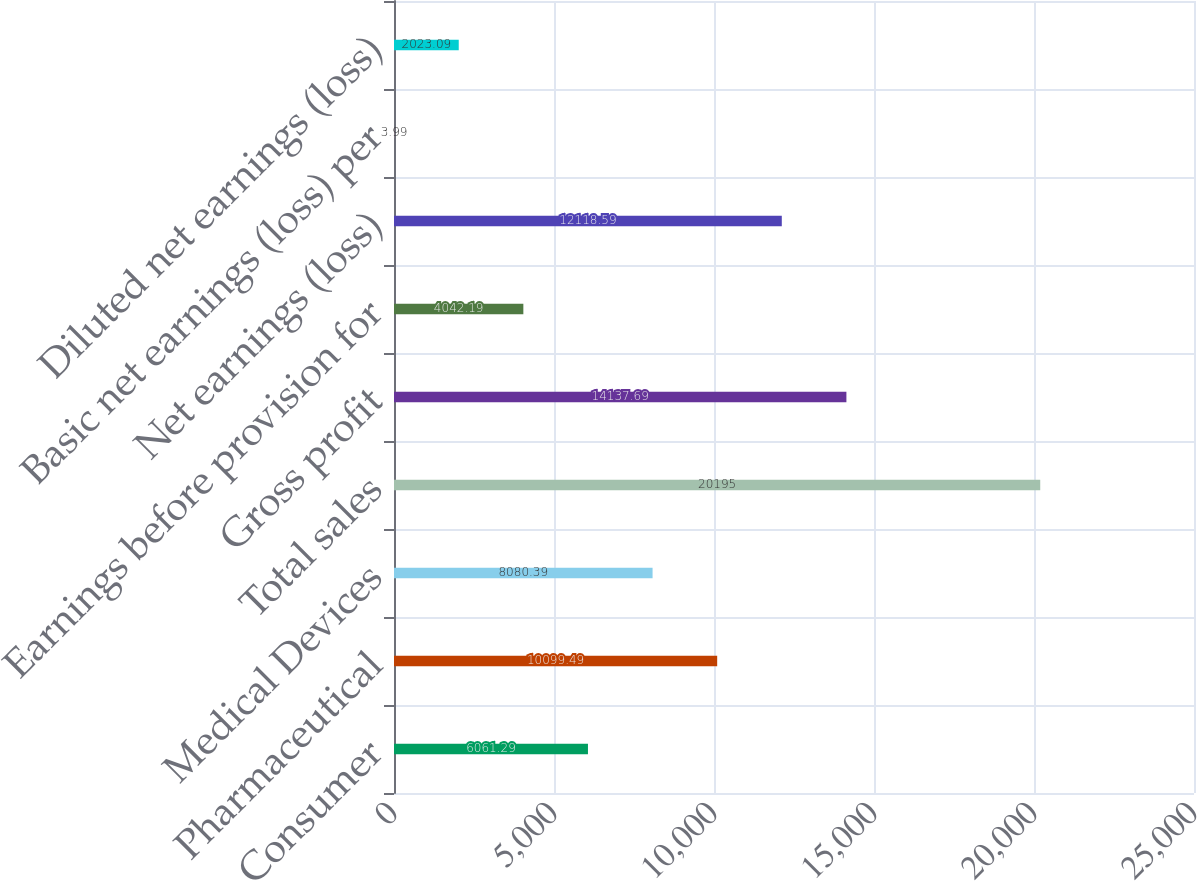Convert chart. <chart><loc_0><loc_0><loc_500><loc_500><bar_chart><fcel>Consumer<fcel>Pharmaceutical<fcel>Medical Devices<fcel>Total sales<fcel>Gross profit<fcel>Earnings before provision for<fcel>Net earnings (loss)<fcel>Basic net earnings (loss) per<fcel>Diluted net earnings (loss)<nl><fcel>6061.29<fcel>10099.5<fcel>8080.39<fcel>20195<fcel>14137.7<fcel>4042.19<fcel>12118.6<fcel>3.99<fcel>2023.09<nl></chart> 